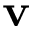Convert formula to latex. <formula><loc_0><loc_0><loc_500><loc_500>v</formula> 